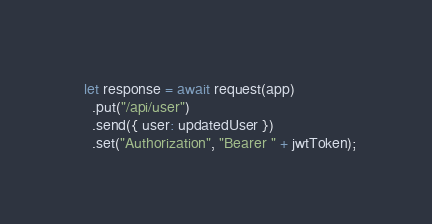Convert code to text. <code><loc_0><loc_0><loc_500><loc_500><_JavaScript_>
  let response = await request(app)
    .put("/api/user")
    .send({ user: updatedUser })
    .set("Authorization", "Bearer " + jwtToken);
</code> 